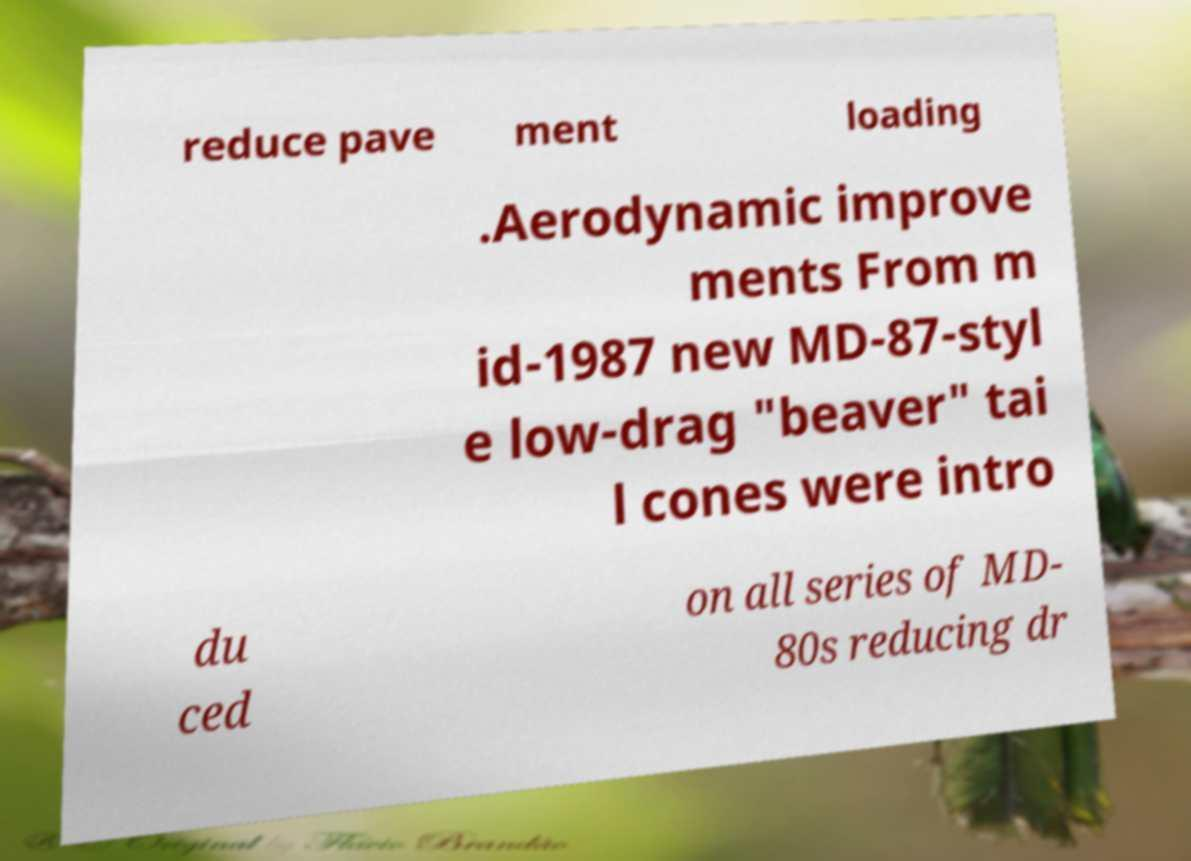Please identify and transcribe the text found in this image. reduce pave ment loading .Aerodynamic improve ments From m id-1987 new MD-87-styl e low-drag "beaver" tai l cones were intro du ced on all series of MD- 80s reducing dr 